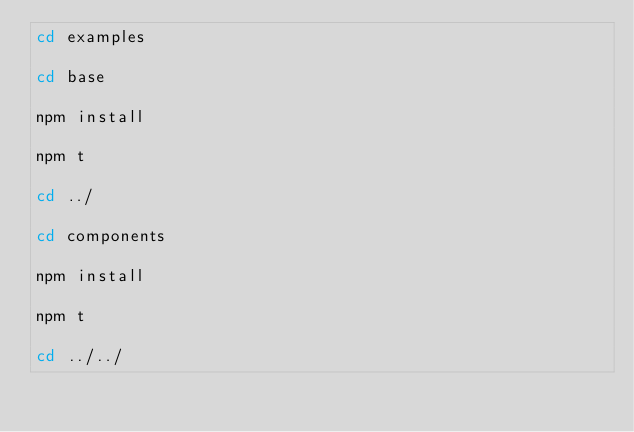Convert code to text. <code><loc_0><loc_0><loc_500><loc_500><_Bash_>cd examples

cd base

npm install

npm t

cd ../

cd components

npm install 

npm t

cd ../../</code> 